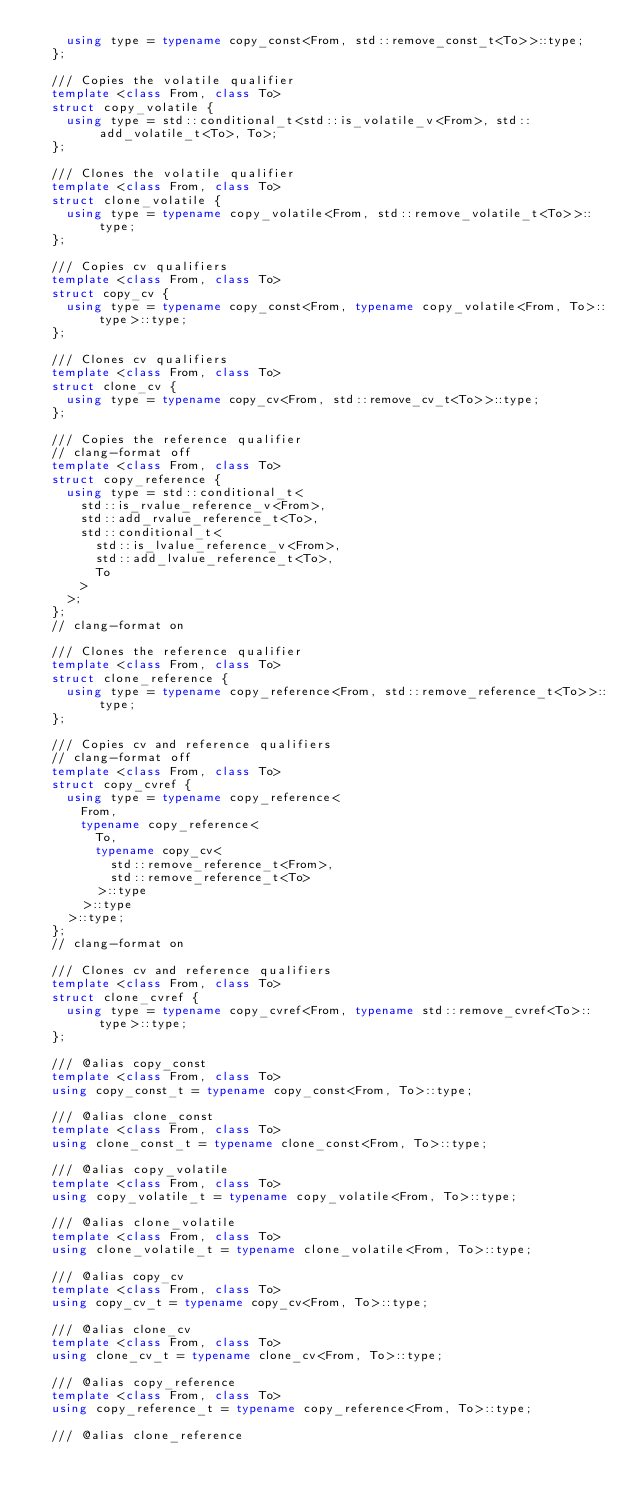Convert code to text. <code><loc_0><loc_0><loc_500><loc_500><_C++_>    using type = typename copy_const<From, std::remove_const_t<To>>::type;
  };

  /// Copies the volatile qualifier
  template <class From, class To>
  struct copy_volatile {
    using type = std::conditional_t<std::is_volatile_v<From>, std::add_volatile_t<To>, To>;
  };

  /// Clones the volatile qualifier
  template <class From, class To>
  struct clone_volatile {
    using type = typename copy_volatile<From, std::remove_volatile_t<To>>::type;
  };

  /// Copies cv qualifiers
  template <class From, class To>
  struct copy_cv {
    using type = typename copy_const<From, typename copy_volatile<From, To>::type>::type;
  };

  /// Clones cv qualifiers
  template <class From, class To>
  struct clone_cv {
    using type = typename copy_cv<From, std::remove_cv_t<To>>::type;
  };

  /// Copies the reference qualifier
  // clang-format off
  template <class From, class To>
  struct copy_reference {
    using type = std::conditional_t<
      std::is_rvalue_reference_v<From>,
      std::add_rvalue_reference_t<To>,
      std::conditional_t<
        std::is_lvalue_reference_v<From>,
        std::add_lvalue_reference_t<To>,
        To
      >
    >;
  };
  // clang-format on

  /// Clones the reference qualifier
  template <class From, class To>
  struct clone_reference {
    using type = typename copy_reference<From, std::remove_reference_t<To>>::type;
  };

  /// Copies cv and reference qualifiers
  // clang-format off
  template <class From, class To>
  struct copy_cvref {
    using type = typename copy_reference<
      From,
      typename copy_reference<
        To,
        typename copy_cv<
          std::remove_reference_t<From>,
          std::remove_reference_t<To>
        >::type
      >::type
    >::type;
  };
  // clang-format on

  /// Clones cv and reference qualifiers
  template <class From, class To>
  struct clone_cvref {
    using type = typename copy_cvref<From, typename std::remove_cvref<To>::type>::type;
  };

  /// @alias copy_const
  template <class From, class To>
  using copy_const_t = typename copy_const<From, To>::type;

  /// @alias clone_const
  template <class From, class To>
  using clone_const_t = typename clone_const<From, To>::type;

  /// @alias copy_volatile
  template <class From, class To>
  using copy_volatile_t = typename copy_volatile<From, To>::type;

  /// @alias clone_volatile
  template <class From, class To>
  using clone_volatile_t = typename clone_volatile<From, To>::type;

  /// @alias copy_cv
  template <class From, class To>
  using copy_cv_t = typename copy_cv<From, To>::type;

  /// @alias clone_cv
  template <class From, class To>
  using clone_cv_t = typename clone_cv<From, To>::type;

  /// @alias copy_reference
  template <class From, class To>
  using copy_reference_t = typename copy_reference<From, To>::type;

  /// @alias clone_reference</code> 